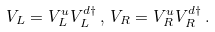<formula> <loc_0><loc_0><loc_500><loc_500>V _ { L } = V ^ { u } _ { L } V ^ { d \dagger } _ { L } \, , \, V _ { R } = V ^ { u } _ { R } V ^ { d \dagger } _ { R } \, .</formula> 